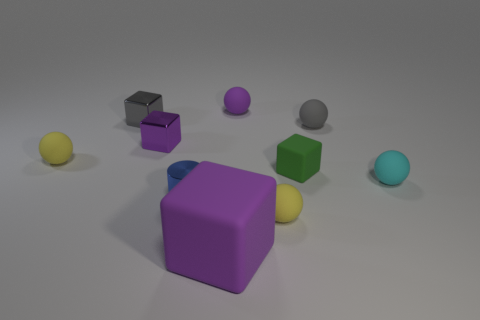The purple matte block has what size?
Provide a succinct answer. Large. How many objects are matte blocks or tiny objects that are to the left of the small gray matte thing?
Provide a succinct answer. 8. What number of other things are the same color as the big object?
Your response must be concise. 2. There is a gray rubber ball; is it the same size as the matte thing to the left of the blue cylinder?
Your answer should be compact. Yes. There is a thing that is right of the gray matte ball; does it have the same size as the small cylinder?
Provide a succinct answer. Yes. How many other things are there of the same material as the large thing?
Make the answer very short. 6. Is the number of tiny gray metal cubes on the right side of the tiny purple block the same as the number of gray rubber spheres that are right of the green matte thing?
Your response must be concise. No. The metal object in front of the small yellow rubber ball that is to the left of the tiny purple thing that is in front of the small gray ball is what color?
Keep it short and to the point. Blue. The large object left of the cyan ball has what shape?
Provide a short and direct response. Cube. What shape is the small gray object that is made of the same material as the cylinder?
Offer a very short reply. Cube. 